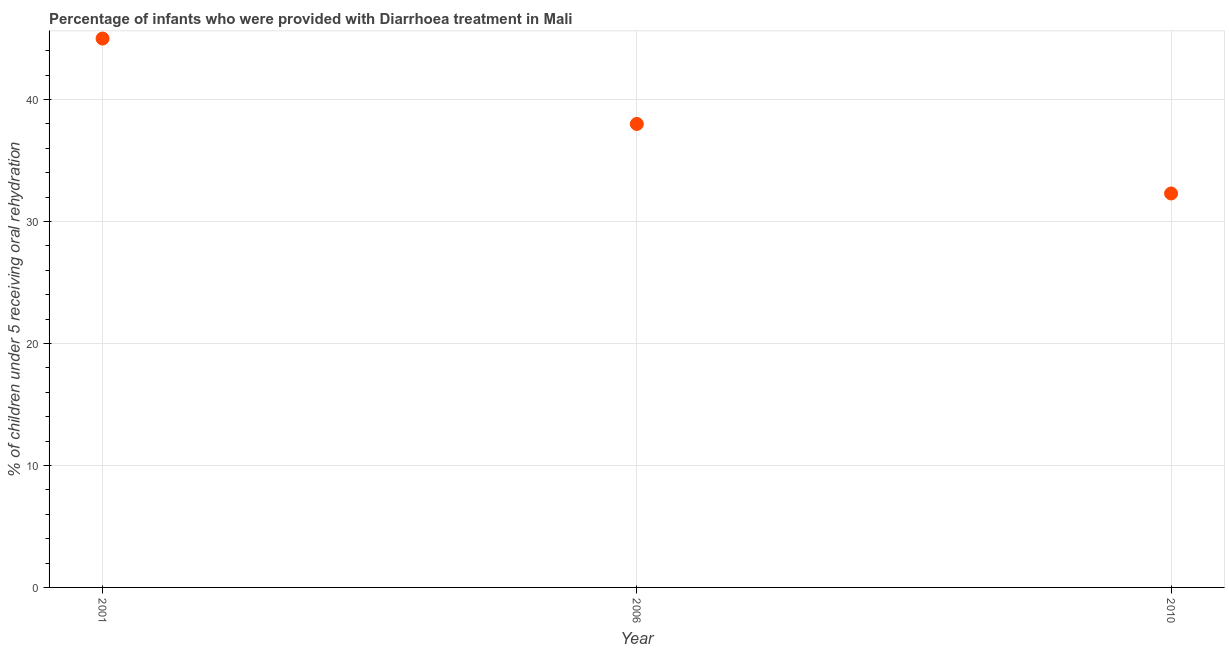What is the percentage of children who were provided with treatment diarrhoea in 2010?
Offer a terse response. 32.3. Across all years, what is the maximum percentage of children who were provided with treatment diarrhoea?
Your answer should be compact. 45. Across all years, what is the minimum percentage of children who were provided with treatment diarrhoea?
Your answer should be compact. 32.3. In which year was the percentage of children who were provided with treatment diarrhoea maximum?
Offer a terse response. 2001. In which year was the percentage of children who were provided with treatment diarrhoea minimum?
Give a very brief answer. 2010. What is the sum of the percentage of children who were provided with treatment diarrhoea?
Your response must be concise. 115.3. What is the difference between the percentage of children who were provided with treatment diarrhoea in 2001 and 2010?
Offer a terse response. 12.7. What is the average percentage of children who were provided with treatment diarrhoea per year?
Make the answer very short. 38.43. What is the median percentage of children who were provided with treatment diarrhoea?
Keep it short and to the point. 38. Do a majority of the years between 2001 and 2006 (inclusive) have percentage of children who were provided with treatment diarrhoea greater than 14 %?
Make the answer very short. Yes. What is the ratio of the percentage of children who were provided with treatment diarrhoea in 2001 to that in 2006?
Provide a succinct answer. 1.18. Is the percentage of children who were provided with treatment diarrhoea in 2006 less than that in 2010?
Offer a terse response. No. Is the sum of the percentage of children who were provided with treatment diarrhoea in 2001 and 2010 greater than the maximum percentage of children who were provided with treatment diarrhoea across all years?
Your answer should be compact. Yes. What is the difference between the highest and the lowest percentage of children who were provided with treatment diarrhoea?
Give a very brief answer. 12.7. In how many years, is the percentage of children who were provided with treatment diarrhoea greater than the average percentage of children who were provided with treatment diarrhoea taken over all years?
Provide a short and direct response. 1. How many dotlines are there?
Give a very brief answer. 1. What is the difference between two consecutive major ticks on the Y-axis?
Give a very brief answer. 10. Are the values on the major ticks of Y-axis written in scientific E-notation?
Offer a very short reply. No. Does the graph contain grids?
Provide a short and direct response. Yes. What is the title of the graph?
Your answer should be very brief. Percentage of infants who were provided with Diarrhoea treatment in Mali. What is the label or title of the X-axis?
Provide a short and direct response. Year. What is the label or title of the Y-axis?
Your response must be concise. % of children under 5 receiving oral rehydration. What is the % of children under 5 receiving oral rehydration in 2010?
Offer a very short reply. 32.3. What is the difference between the % of children under 5 receiving oral rehydration in 2001 and 2006?
Your answer should be very brief. 7. What is the ratio of the % of children under 5 receiving oral rehydration in 2001 to that in 2006?
Offer a very short reply. 1.18. What is the ratio of the % of children under 5 receiving oral rehydration in 2001 to that in 2010?
Make the answer very short. 1.39. What is the ratio of the % of children under 5 receiving oral rehydration in 2006 to that in 2010?
Provide a succinct answer. 1.18. 